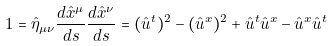<formula> <loc_0><loc_0><loc_500><loc_500>1 = \hat { \eta } _ { \mu \nu } \frac { d \hat { x } ^ { \mu } } { d s } \frac { d \hat { x } ^ { \nu } } { d s } = ( \hat { u } ^ { t } ) ^ { 2 } - ( \hat { u } ^ { x } ) ^ { 2 } + \hat { u } ^ { t } \hat { u } ^ { x } - \hat { u } ^ { x } \hat { u } ^ { t }</formula> 